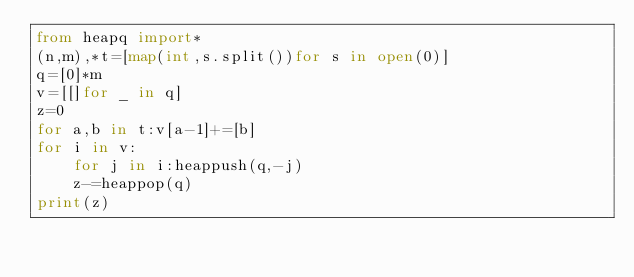<code> <loc_0><loc_0><loc_500><loc_500><_Python_>from heapq import*
(n,m),*t=[map(int,s.split())for s in open(0)]
q=[0]*m
v=[[]for _ in q]
z=0
for a,b in t:v[a-1]+=[b]
for i in v:
	for j in i:heappush(q,-j)
	z-=heappop(q)
print(z)</code> 